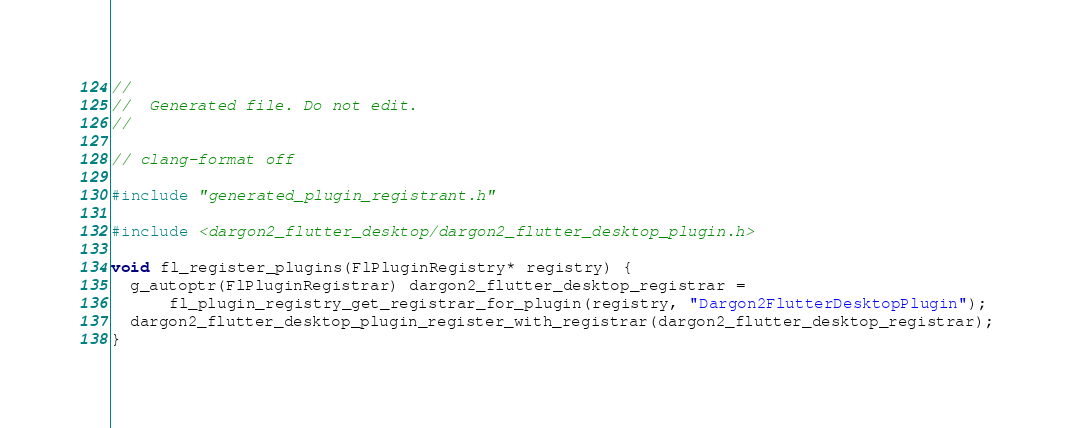Convert code to text. <code><loc_0><loc_0><loc_500><loc_500><_C++_>//
//  Generated file. Do not edit.
//

// clang-format off

#include "generated_plugin_registrant.h"

#include <dargon2_flutter_desktop/dargon2_flutter_desktop_plugin.h>

void fl_register_plugins(FlPluginRegistry* registry) {
  g_autoptr(FlPluginRegistrar) dargon2_flutter_desktop_registrar =
      fl_plugin_registry_get_registrar_for_plugin(registry, "Dargon2FlutterDesktopPlugin");
  dargon2_flutter_desktop_plugin_register_with_registrar(dargon2_flutter_desktop_registrar);
}
</code> 